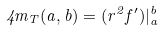<formula> <loc_0><loc_0><loc_500><loc_500>4 m _ { T } ( a , b ) = ( r ^ { 2 } f ^ { \prime } ) | _ { a } ^ { b }</formula> 